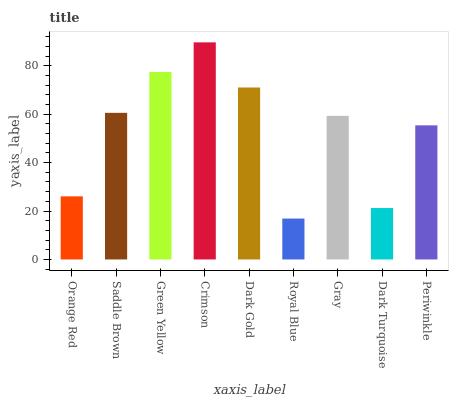Is Royal Blue the minimum?
Answer yes or no. Yes. Is Crimson the maximum?
Answer yes or no. Yes. Is Saddle Brown the minimum?
Answer yes or no. No. Is Saddle Brown the maximum?
Answer yes or no. No. Is Saddle Brown greater than Orange Red?
Answer yes or no. Yes. Is Orange Red less than Saddle Brown?
Answer yes or no. Yes. Is Orange Red greater than Saddle Brown?
Answer yes or no. No. Is Saddle Brown less than Orange Red?
Answer yes or no. No. Is Gray the high median?
Answer yes or no. Yes. Is Gray the low median?
Answer yes or no. Yes. Is Dark Turquoise the high median?
Answer yes or no. No. Is Royal Blue the low median?
Answer yes or no. No. 